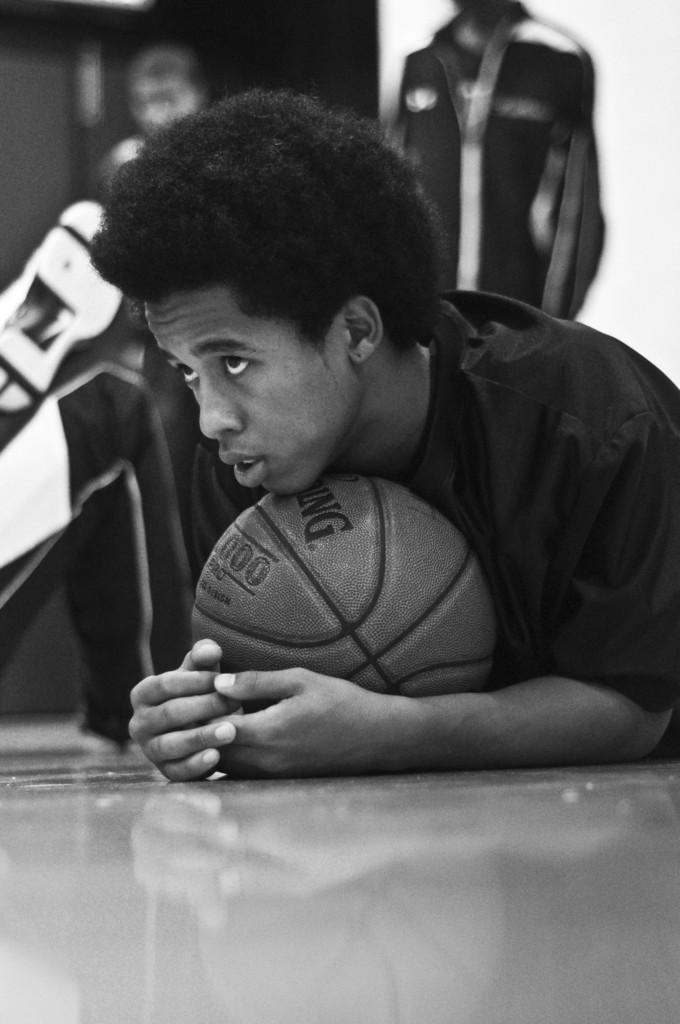What is the main subject of the image? There is a person in the image. What is the person doing in the image? The person is on the floor and holding a ball. Can you describe the background of the image? The background of the image is blurred. What type of whistle can be heard in the image? There is no whistle present in the image, and therefore no sound can be heard. What is the person in the image laughing at? The image does not show the person laughing or any indication of what they might be laughing at. 